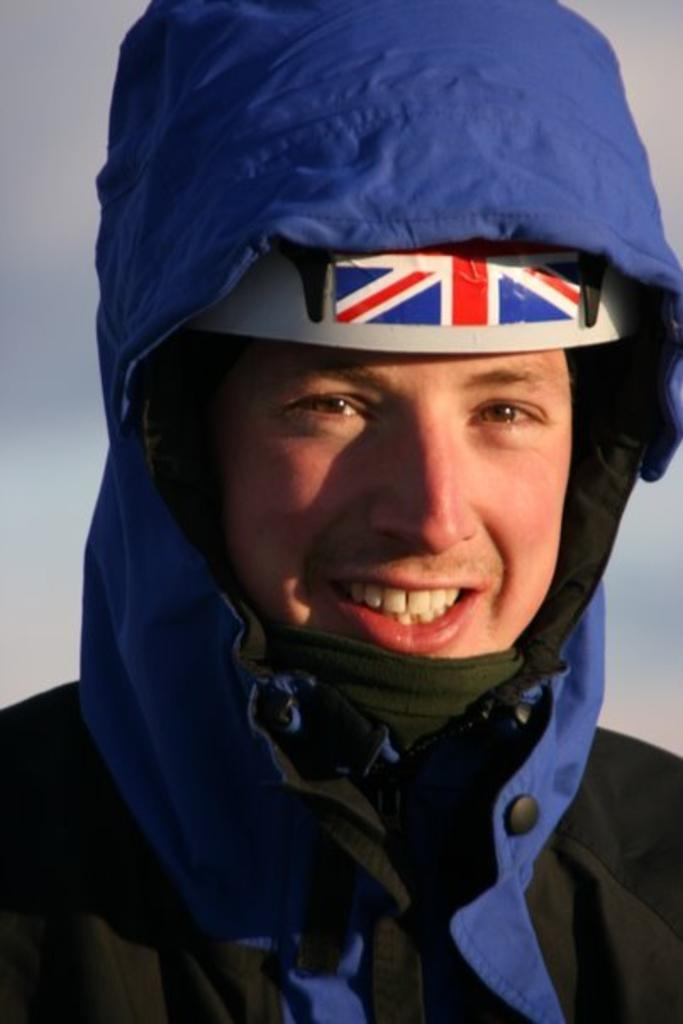Who is present in the image? There is a man in the picture. What is the man wearing? The man is wearing a coat. What is the man's facial expression in the image? The man is smiling. What type of sack is the man carrying in the image? There is no sack present in the image. What is the man rubbing on his face in the image? There is no rubbing or any other action involving the man's face depicted in the image. 